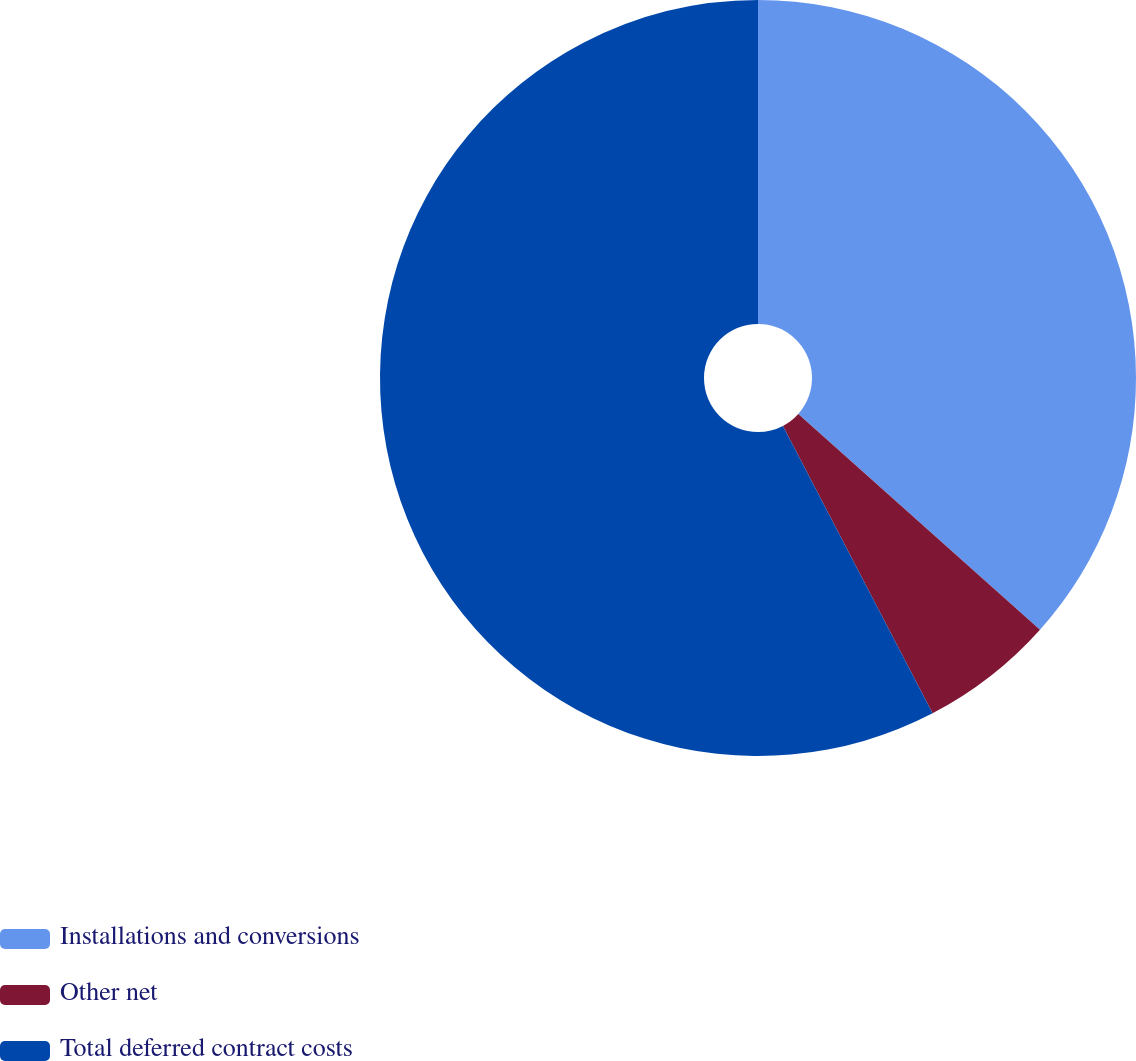Convert chart. <chart><loc_0><loc_0><loc_500><loc_500><pie_chart><fcel>Installations and conversions<fcel>Other net<fcel>Total deferred contract costs<nl><fcel>36.6%<fcel>5.76%<fcel>57.64%<nl></chart> 